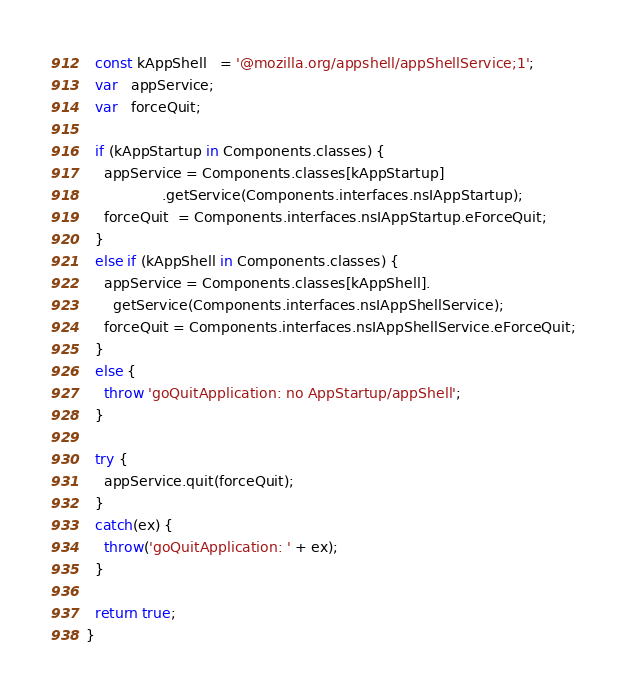Convert code to text. <code><loc_0><loc_0><loc_500><loc_500><_JavaScript_>  const kAppShell   = '@mozilla.org/appshell/appShellService;1';
  var   appService;
  var   forceQuit;

  if (kAppStartup in Components.classes) {
    appService = Components.classes[kAppStartup]
                 .getService(Components.interfaces.nsIAppStartup);
    forceQuit  = Components.interfaces.nsIAppStartup.eForceQuit;
  }
  else if (kAppShell in Components.classes) {
    appService = Components.classes[kAppShell].
      getService(Components.interfaces.nsIAppShellService);
    forceQuit = Components.interfaces.nsIAppShellService.eForceQuit;
  }
  else {
    throw 'goQuitApplication: no AppStartup/appShell';
  }

  try {
    appService.quit(forceQuit);
  }
  catch(ex) {
    throw('goQuitApplication: ' + ex);
  }

  return true;
}

</code> 